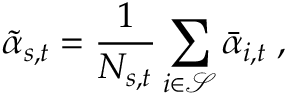Convert formula to latex. <formula><loc_0><loc_0><loc_500><loc_500>\tilde { \alpha } _ { s , t } = \frac { 1 } { N _ { s , t } } \sum _ { i \in \mathcal { S } } \bar { \alpha } _ { i , t } \, ,</formula> 